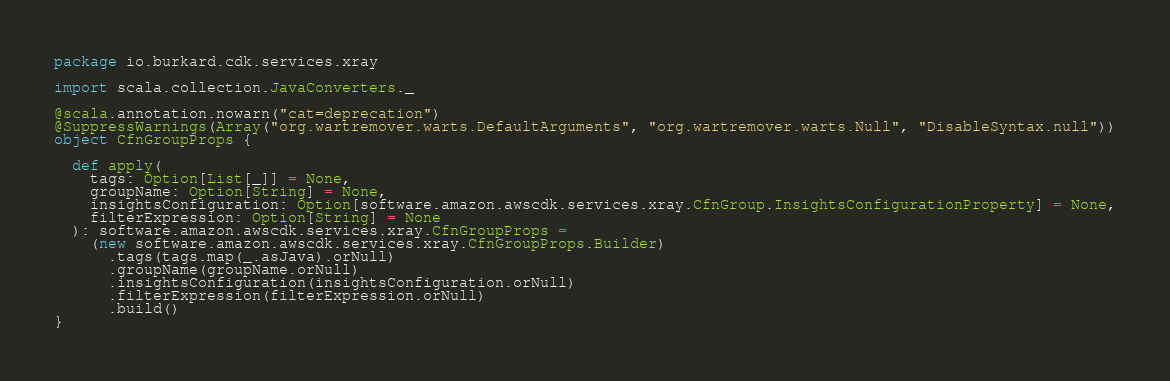Convert code to text. <code><loc_0><loc_0><loc_500><loc_500><_Scala_>package io.burkard.cdk.services.xray

import scala.collection.JavaConverters._

@scala.annotation.nowarn("cat=deprecation")
@SuppressWarnings(Array("org.wartremover.warts.DefaultArguments", "org.wartremover.warts.Null", "DisableSyntax.null"))
object CfnGroupProps {

  def apply(
    tags: Option[List[_]] = None,
    groupName: Option[String] = None,
    insightsConfiguration: Option[software.amazon.awscdk.services.xray.CfnGroup.InsightsConfigurationProperty] = None,
    filterExpression: Option[String] = None
  ): software.amazon.awscdk.services.xray.CfnGroupProps =
    (new software.amazon.awscdk.services.xray.CfnGroupProps.Builder)
      .tags(tags.map(_.asJava).orNull)
      .groupName(groupName.orNull)
      .insightsConfiguration(insightsConfiguration.orNull)
      .filterExpression(filterExpression.orNull)
      .build()
}
</code> 